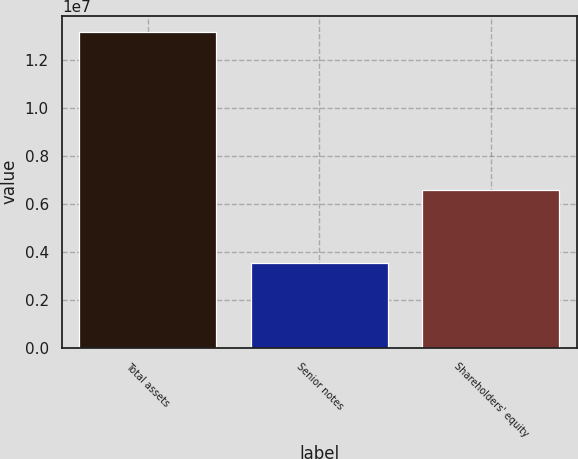Convert chart to OTSL. <chart><loc_0><loc_0><loc_500><loc_500><bar_chart><fcel>Total assets<fcel>Senior notes<fcel>Shareholders' equity<nl><fcel>1.31769e+07<fcel>3.53795e+06<fcel>6.57736e+06<nl></chart> 